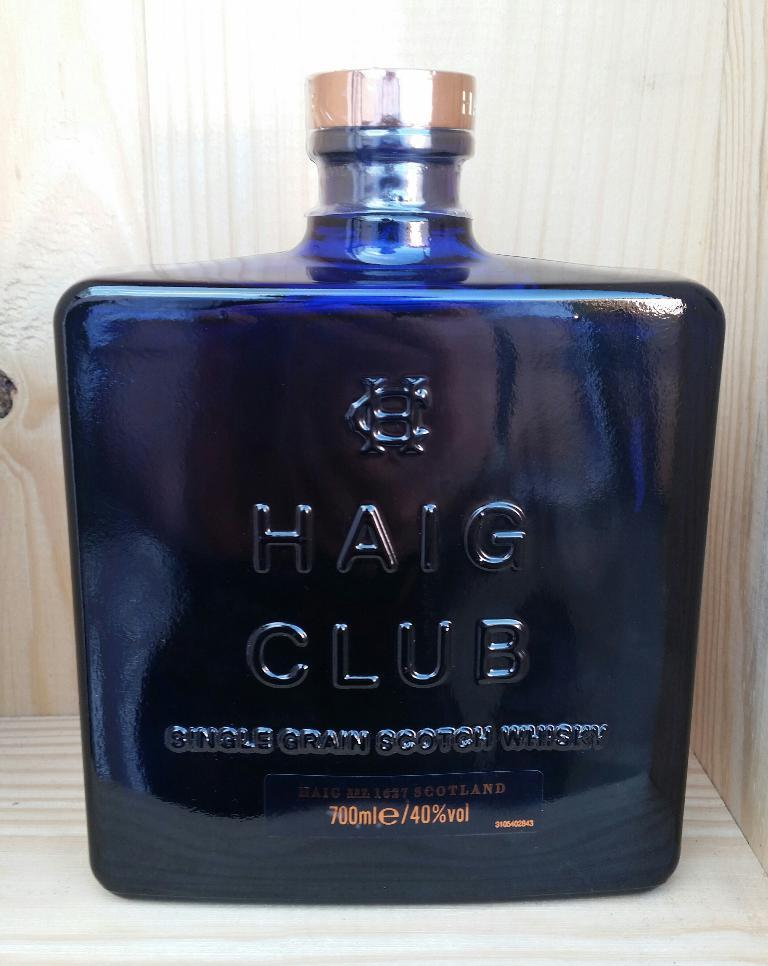Provide a one-sentence caption for the provided image. HAIG CLUB single grain scotch whisky is from Scotland and comes in an attractive blue bottle. 